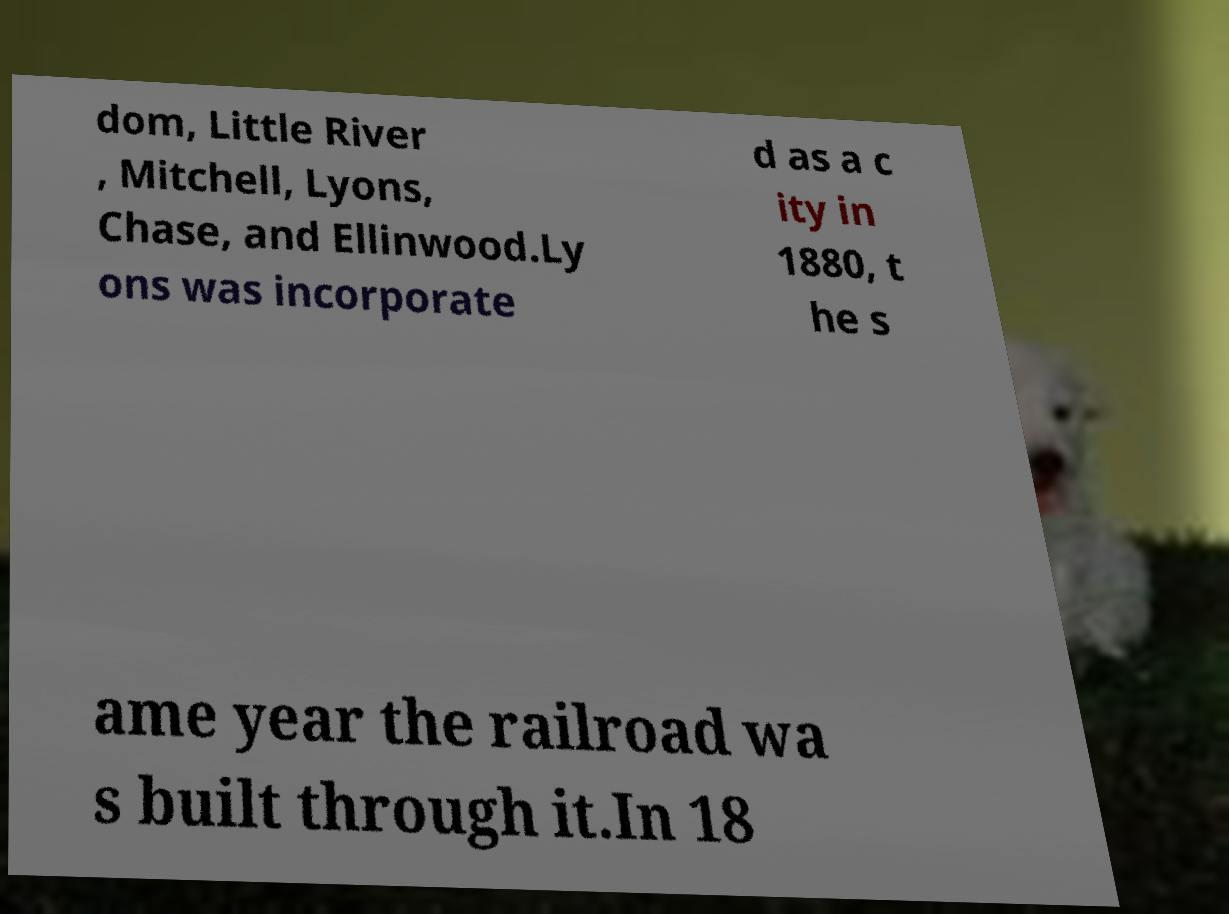For documentation purposes, I need the text within this image transcribed. Could you provide that? dom, Little River , Mitchell, Lyons, Chase, and Ellinwood.Ly ons was incorporate d as a c ity in 1880, t he s ame year the railroad wa s built through it.In 18 